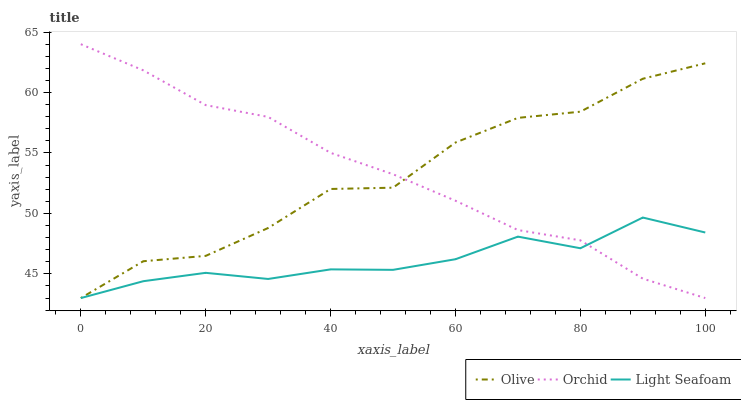Does Light Seafoam have the minimum area under the curve?
Answer yes or no. Yes. Does Orchid have the maximum area under the curve?
Answer yes or no. Yes. Does Orchid have the minimum area under the curve?
Answer yes or no. No. Does Light Seafoam have the maximum area under the curve?
Answer yes or no. No. Is Orchid the smoothest?
Answer yes or no. Yes. Is Olive the roughest?
Answer yes or no. Yes. Is Light Seafoam the smoothest?
Answer yes or no. No. Is Light Seafoam the roughest?
Answer yes or no. No. Does Orchid have the highest value?
Answer yes or no. Yes. Does Light Seafoam have the highest value?
Answer yes or no. No. Does Olive intersect Light Seafoam?
Answer yes or no. Yes. Is Olive less than Light Seafoam?
Answer yes or no. No. Is Olive greater than Light Seafoam?
Answer yes or no. No. 